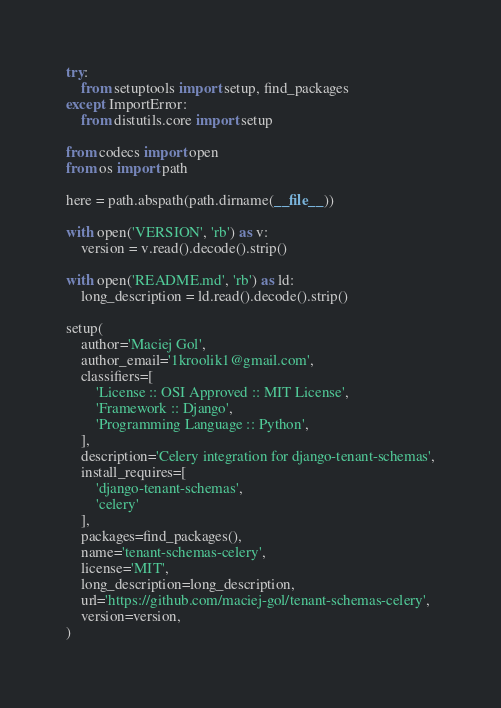Convert code to text. <code><loc_0><loc_0><loc_500><loc_500><_Python_>try:
    from setuptools import setup, find_packages
except ImportError:
    from distutils.core import setup

from codecs import open
from os import path

here = path.abspath(path.dirname(__file__))

with open('VERSION', 'rb') as v:
    version = v.read().decode().strip()

with open('README.md', 'rb') as ld:
    long_description = ld.read().decode().strip()

setup(
    author='Maciej Gol',
    author_email='1kroolik1@gmail.com',
    classifiers=[
        'License :: OSI Approved :: MIT License',
        'Framework :: Django',
        'Programming Language :: Python',
    ],
    description='Celery integration for django-tenant-schemas',
    install_requires=[
        'django-tenant-schemas',
        'celery'
    ],
    packages=find_packages(),
    name='tenant-schemas-celery',
    license='MIT',
    long_description=long_description,
    url='https://github.com/maciej-gol/tenant-schemas-celery',
    version=version,
)
</code> 